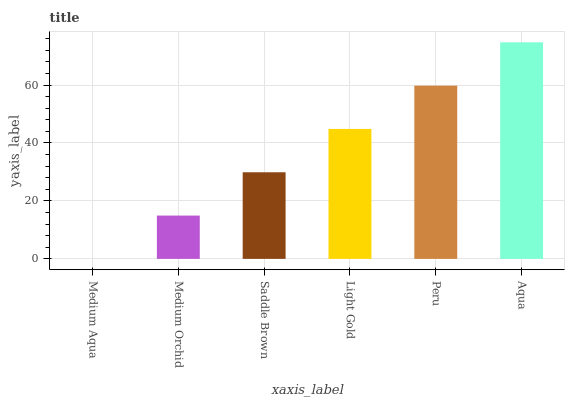Is Medium Aqua the minimum?
Answer yes or no. Yes. Is Aqua the maximum?
Answer yes or no. Yes. Is Medium Orchid the minimum?
Answer yes or no. No. Is Medium Orchid the maximum?
Answer yes or no. No. Is Medium Orchid greater than Medium Aqua?
Answer yes or no. Yes. Is Medium Aqua less than Medium Orchid?
Answer yes or no. Yes. Is Medium Aqua greater than Medium Orchid?
Answer yes or no. No. Is Medium Orchid less than Medium Aqua?
Answer yes or no. No. Is Light Gold the high median?
Answer yes or no. Yes. Is Saddle Brown the low median?
Answer yes or no. Yes. Is Saddle Brown the high median?
Answer yes or no. No. Is Peru the low median?
Answer yes or no. No. 